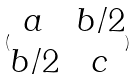Convert formula to latex. <formula><loc_0><loc_0><loc_500><loc_500>( \begin{matrix} a & b / 2 \\ b / 2 & c \end{matrix} )</formula> 